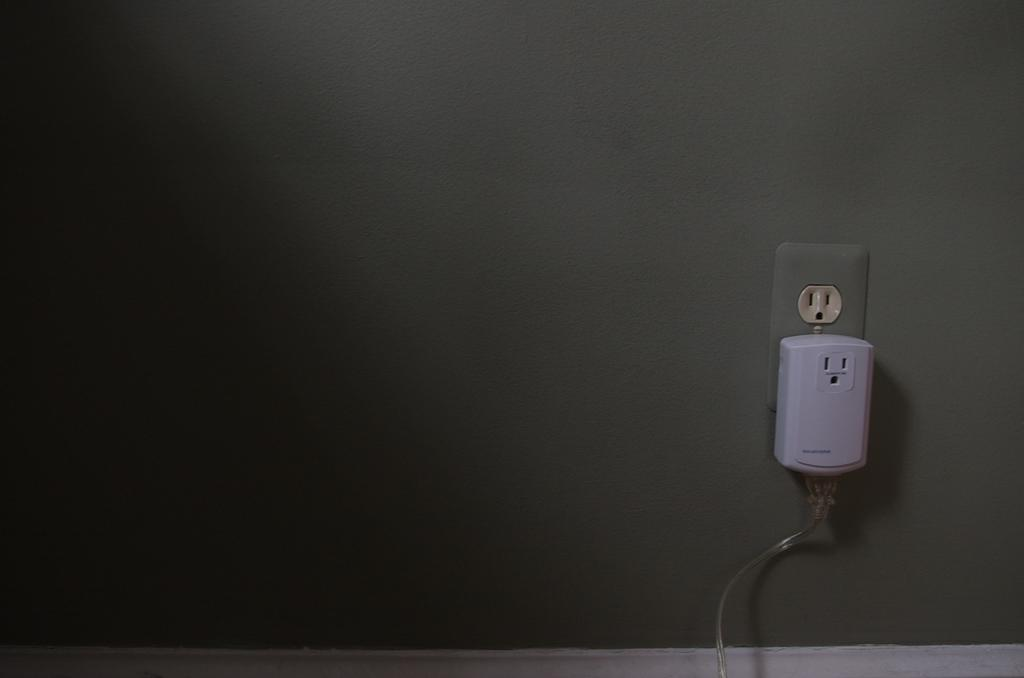What is present on the wall in the image? There is a wall in the image with sockets. What is connected to the sockets on the wall? There is an adapter plugged into a socket. Is there any additional equipment connected to the adapter? Yes, there is a cable connected to the adapter. What type of marble can be seen on the wall in the image? There is no marble present on the wall in the image; it is a regular wall with sockets. Can you see someone blowing into the adapter in the image? No, there is no one blowing into the adapter in the image. 